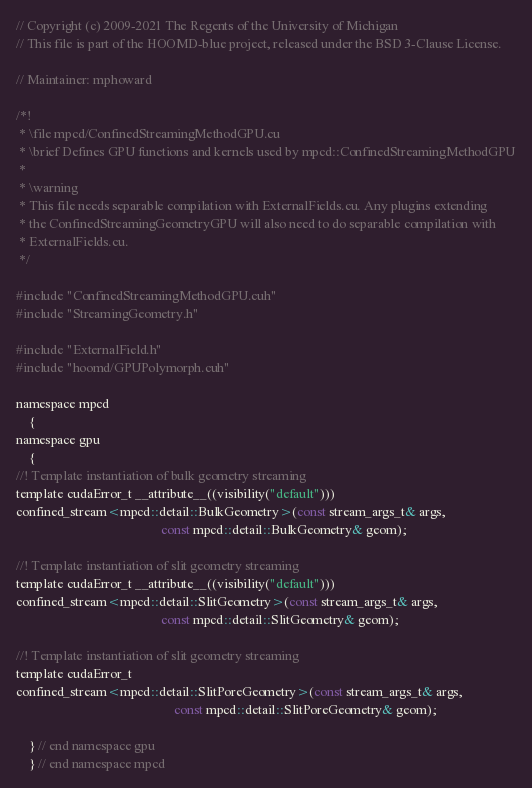Convert code to text. <code><loc_0><loc_0><loc_500><loc_500><_Cuda_>// Copyright (c) 2009-2021 The Regents of the University of Michigan
// This file is part of the HOOMD-blue project, released under the BSD 3-Clause License.

// Maintainer: mphoward

/*!
 * \file mpcd/ConfinedStreamingMethodGPU.cu
 * \brief Defines GPU functions and kernels used by mpcd::ConfinedStreamingMethodGPU
 *
 * \warning
 * This file needs separable compilation with ExternalFields.cu. Any plugins extending
 * the ConfinedStreamingGeometryGPU will also need to do separable compilation with
 * ExternalFields.cu.
 */

#include "ConfinedStreamingMethodGPU.cuh"
#include "StreamingGeometry.h"

#include "ExternalField.h"
#include "hoomd/GPUPolymorph.cuh"

namespace mpcd
    {
namespace gpu
    {
//! Template instantiation of bulk geometry streaming
template cudaError_t __attribute__((visibility("default")))
confined_stream<mpcd::detail::BulkGeometry>(const stream_args_t& args,
                                            const mpcd::detail::BulkGeometry& geom);

//! Template instantiation of slit geometry streaming
template cudaError_t __attribute__((visibility("default")))
confined_stream<mpcd::detail::SlitGeometry>(const stream_args_t& args,
                                            const mpcd::detail::SlitGeometry& geom);

//! Template instantiation of slit geometry streaming
template cudaError_t
confined_stream<mpcd::detail::SlitPoreGeometry>(const stream_args_t& args,
                                                const mpcd::detail::SlitPoreGeometry& geom);

    } // end namespace gpu
    } // end namespace mpcd
</code> 